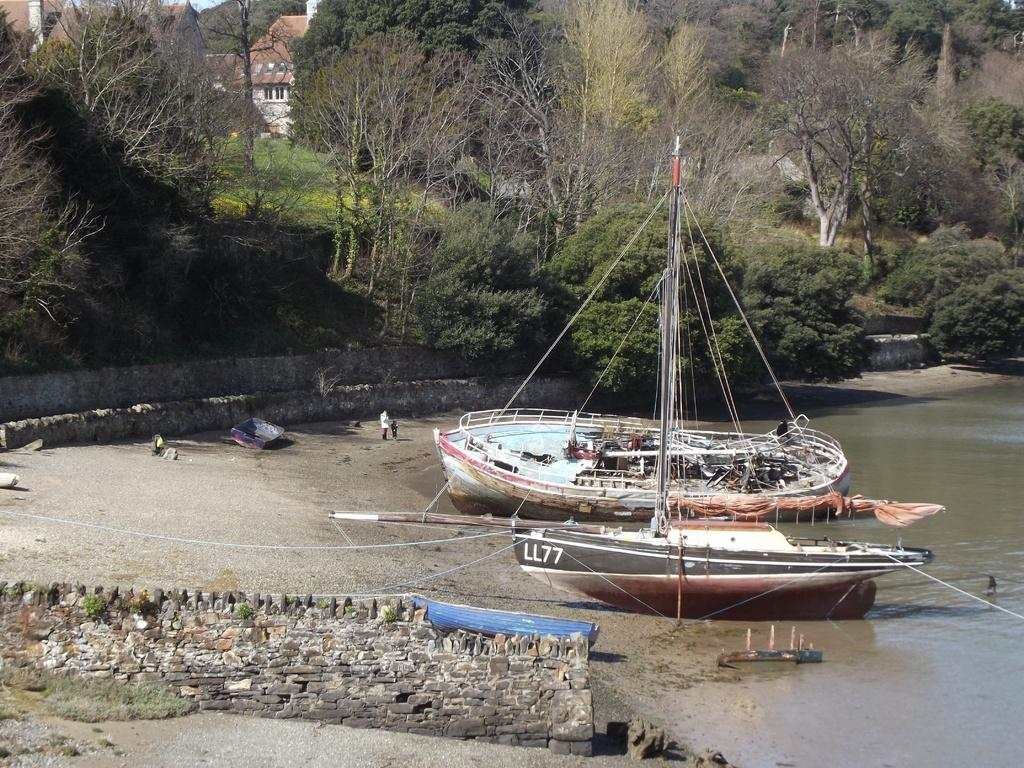What is one of the main features in the image? There is a wall in the image. What can be seen near the wall? There is water visible in the image. Who or what is present in the image? There are persons and ships in the image. What can be seen in the distance in the image? There are trees and houses in the background of the image. What news is being discussed by the persons in the image? There is no indication in the image that the persons are discussing any news, so it cannot be determined from the picture. 